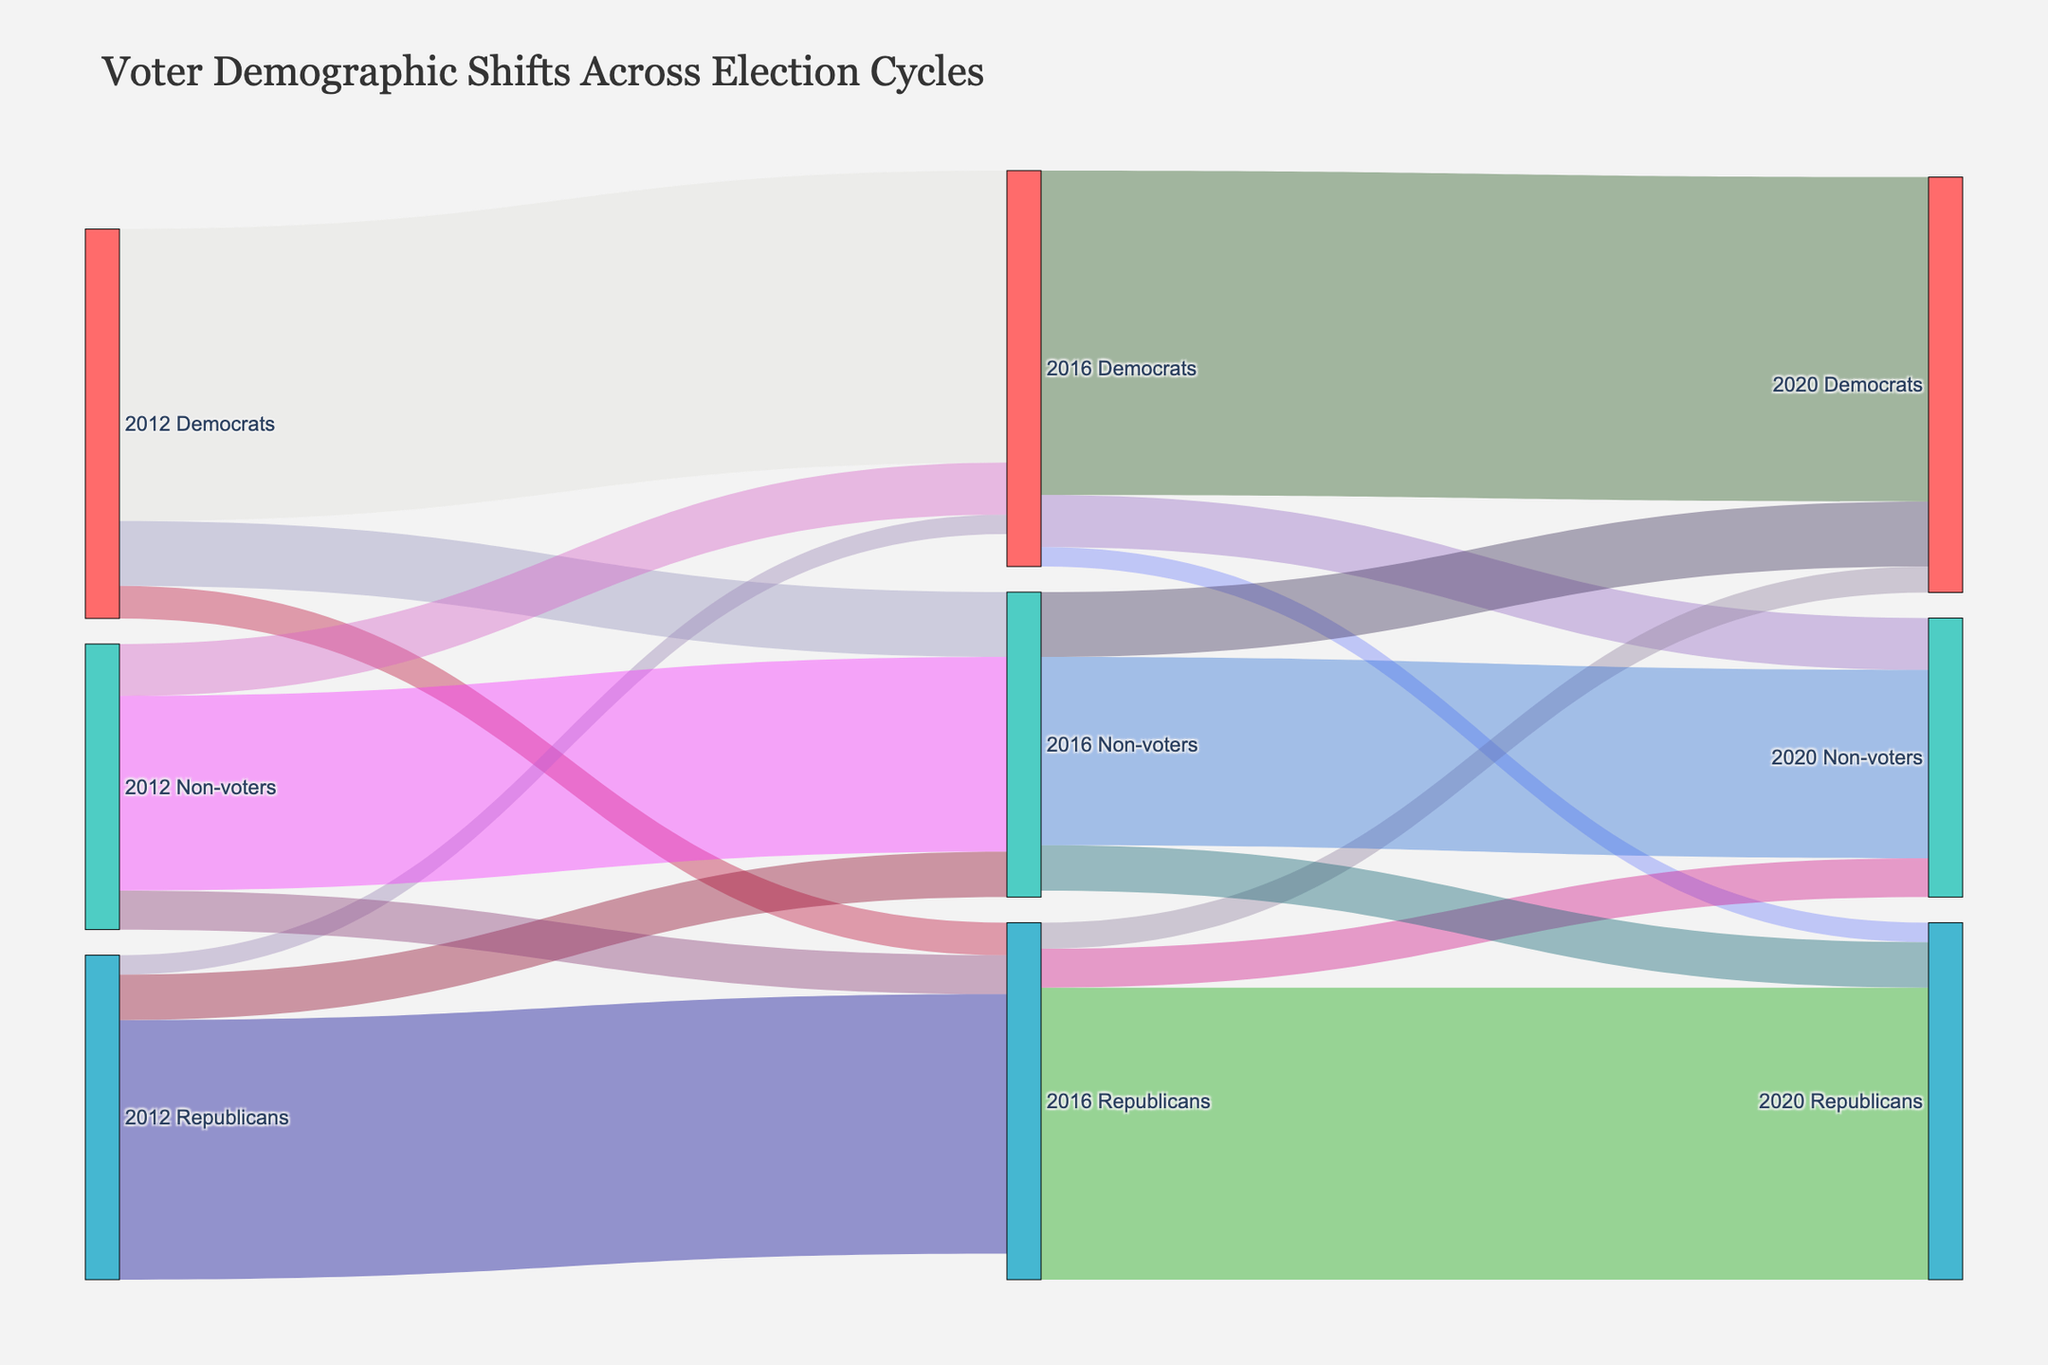What's the title of the figure? The title is typically found at the top of the Sankey Diagram and summarizes the overall purpose or content of the figure. In this case, the title clearly states, "Voter Demographic Shifts Across Election Cycles."
Answer: Voter Demographic Shifts Across Election Cycles What is the thickness of the nodes in the Sankey Diagram? The thickness of the nodes is given in the plot specification. According to the provided code, the thickness of the nodes is set to 20.
Answer: 20 How many individuals who were Democrats in 2012 remained Democrats in 2016? The flow from "2012 Democrats" to "2016 Democrats" represents the number of individuals who stayed with the Democratic Party from 2012 to 2016. This value is directly given in the plot data as 45,000,000.
Answer: 45,000,000 How many individuals who were Republicans in 2012 became Non-voters in 2016? The flow from "2012 Republicans" to "2016 Non-voters" indicates the number of individuals who shifted from being Republicans in 2012 to not voting in 2016. The value shown in the plot data is 7,000,000.
Answer: 7,000,000 What's the net change of Democrat voters from 2016 to 2020 considering all shifts? To find the net change, we sum up the flows into and out of Democrat voters from 2016: 50,000,000 (stayed) + 10,000,000 (non-voters) - 3,000,000 (to Republicans) - 8,000,000 (to non-voters). This results in a net gain of 49,000,000 - 11,000,000 = 39,000,000.
Answer: 39,000,000 Which election cycle shows the highest retention of Republican voters? By examining the values of Republican voters who stayed with their party in the given election cycles: 40,000,000 from 2012 to 2016 and 45,000,000 from 2016 to 2020, the highest retention is seen in the cycle from 2016 to 2020.
Answer: 2016 to 2020 Compare the number of voters who moved from being Non-voters in 2012 to becoming Democrats in 2016 with those who moved from being Non-voters in 2016 to becoming Democrats in 2020. From the data: 8,000,000 non-voters in 2012 became Democrats in 2016, and 10,000,000 non-voters in 2016 became Democrats in 2020. Thus, more non-voters shifted to Democrats between 2016 and 2020 compared to 2012 and 2016.
Answer: 10,000,000 vs 8,000,000 What percentage of 2016 Republicans became Democrats in 2020? To calculate the percentage, we take the flow from "2016 Republicans" to "2020 Democrats" (4,000,000) divided by the total number of 2016 Republicans (40,000,000 + 3,000,000 + 7,000,000) resulting in \( \frac{4,000,000}{50,000,000} \times 100 \approx 8\% \).
Answer: 8% What is the total number of voters who became Non-voters in 2020? The total number of voters who became Non-voters in 2020 can be found by summing all incoming flows to "2020 Non-voters": 8,000,000 (Democrats) + 6,000,000 (Republicans) + 29,000,000 (Non-voters), which equals 43,000,000.
Answer: 43,000,000 